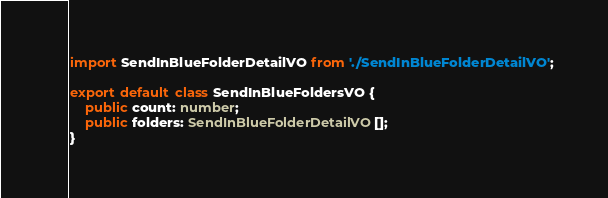Convert code to text. <code><loc_0><loc_0><loc_500><loc_500><_TypeScript_>import SendInBlueFolderDetailVO from './SendInBlueFolderDetailVO';

export default class SendInBlueFoldersVO {
    public count: number;
    public folders: SendInBlueFolderDetailVO[];
}</code> 